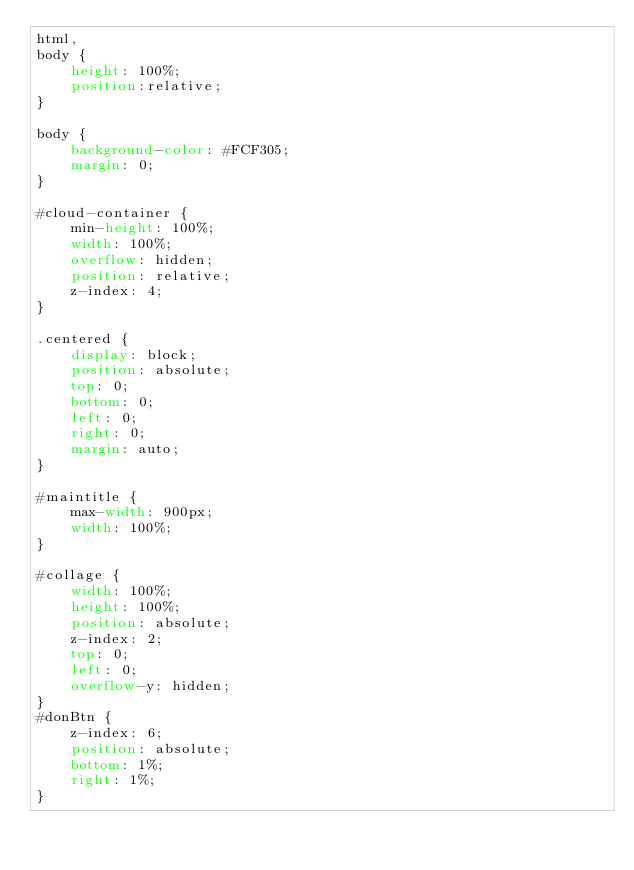<code> <loc_0><loc_0><loc_500><loc_500><_CSS_>html,
body {
    height: 100%;
    position:relative;
}

body {
    background-color: #FCF305;
    margin: 0;
}

#cloud-container {
    min-height: 100%;
    width: 100%;
    overflow: hidden;
    position: relative;
    z-index: 4;
}

.centered {
    display: block;
    position: absolute;
    top: 0;
    bottom: 0;
    left: 0;
    right: 0;
    margin: auto;
}

#maintitle {
    max-width: 900px;
    width: 100%;
}

#collage {
    width: 100%;
    height: 100%;
    position: absolute;
    z-index: 2;
    top: 0;
    left: 0;
    overflow-y: hidden;
}
#donBtn {
    z-index: 6;
    position: absolute;
    bottom: 1%;
    right: 1%;
}
</code> 